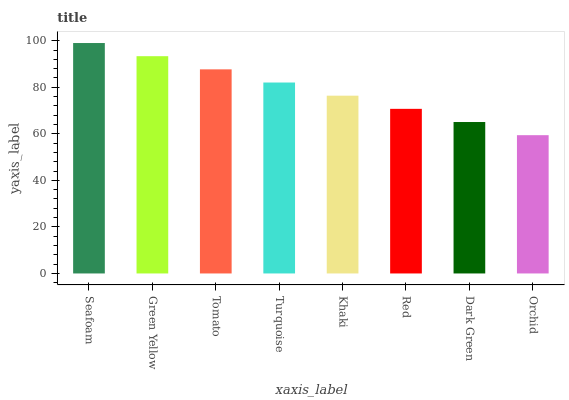Is Orchid the minimum?
Answer yes or no. Yes. Is Seafoam the maximum?
Answer yes or no. Yes. Is Green Yellow the minimum?
Answer yes or no. No. Is Green Yellow the maximum?
Answer yes or no. No. Is Seafoam greater than Green Yellow?
Answer yes or no. Yes. Is Green Yellow less than Seafoam?
Answer yes or no. Yes. Is Green Yellow greater than Seafoam?
Answer yes or no. No. Is Seafoam less than Green Yellow?
Answer yes or no. No. Is Turquoise the high median?
Answer yes or no. Yes. Is Khaki the low median?
Answer yes or no. Yes. Is Dark Green the high median?
Answer yes or no. No. Is Dark Green the low median?
Answer yes or no. No. 